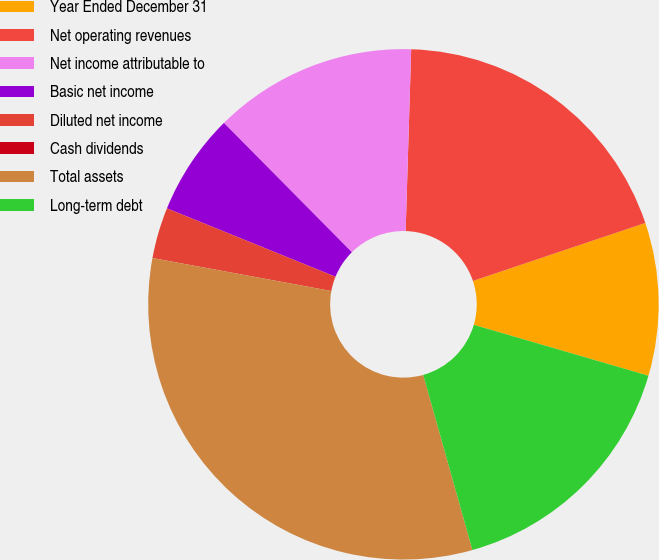Convert chart to OTSL. <chart><loc_0><loc_0><loc_500><loc_500><pie_chart><fcel>Year Ended December 31<fcel>Net operating revenues<fcel>Net income attributable to<fcel>Basic net income<fcel>Diluted net income<fcel>Cash dividends<fcel>Total assets<fcel>Long-term debt<nl><fcel>9.68%<fcel>19.35%<fcel>12.9%<fcel>6.45%<fcel>3.23%<fcel>0.0%<fcel>32.26%<fcel>16.13%<nl></chart> 